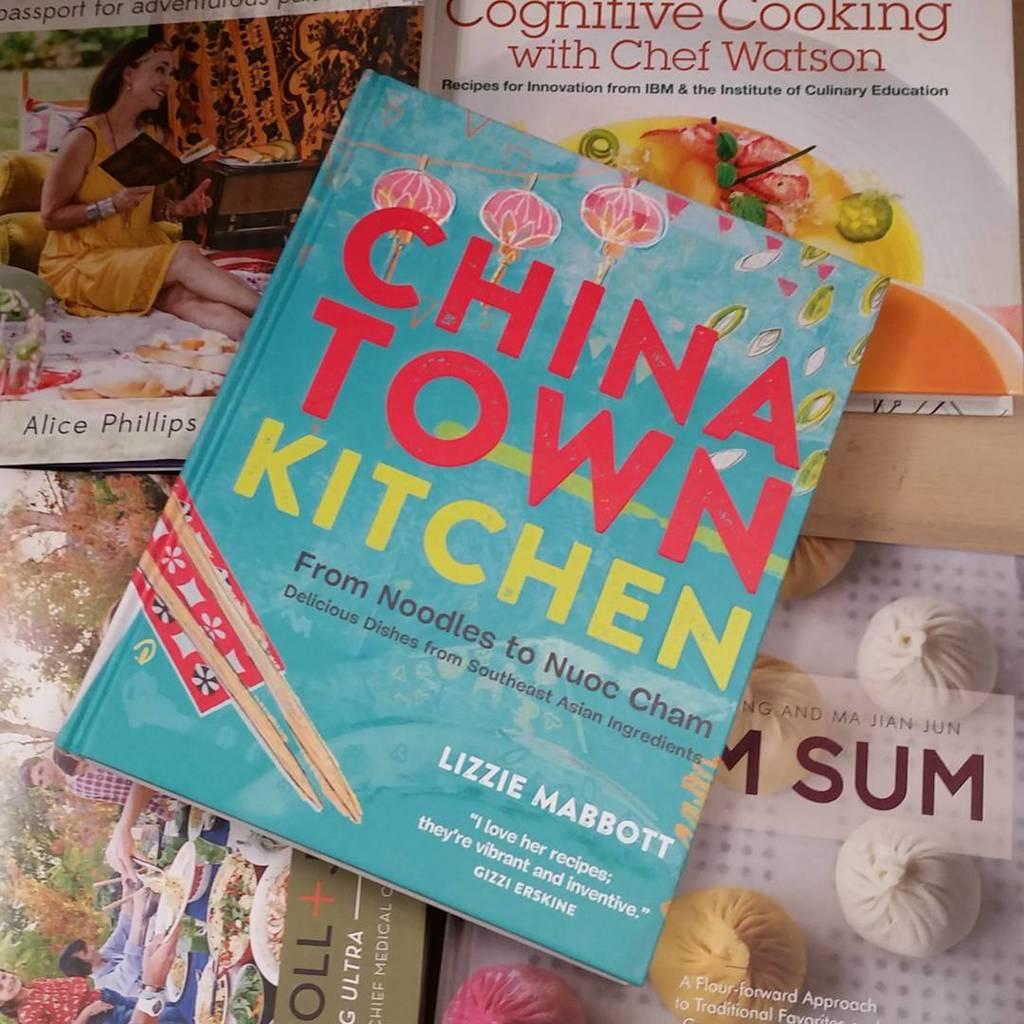Provide a one-sentence caption for the provided image. A book called China Town Kitchen has a bright blue color and includes noodle recipes. 